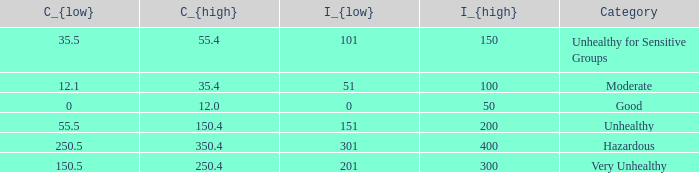How many different C_{high} values are there for the good category? 1.0. 